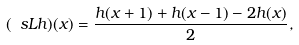<formula> <loc_0><loc_0><loc_500><loc_500>( \ s L h ) ( x ) = \frac { h ( x + 1 ) + h ( x - 1 ) - 2 h ( x ) } { 2 } ,</formula> 